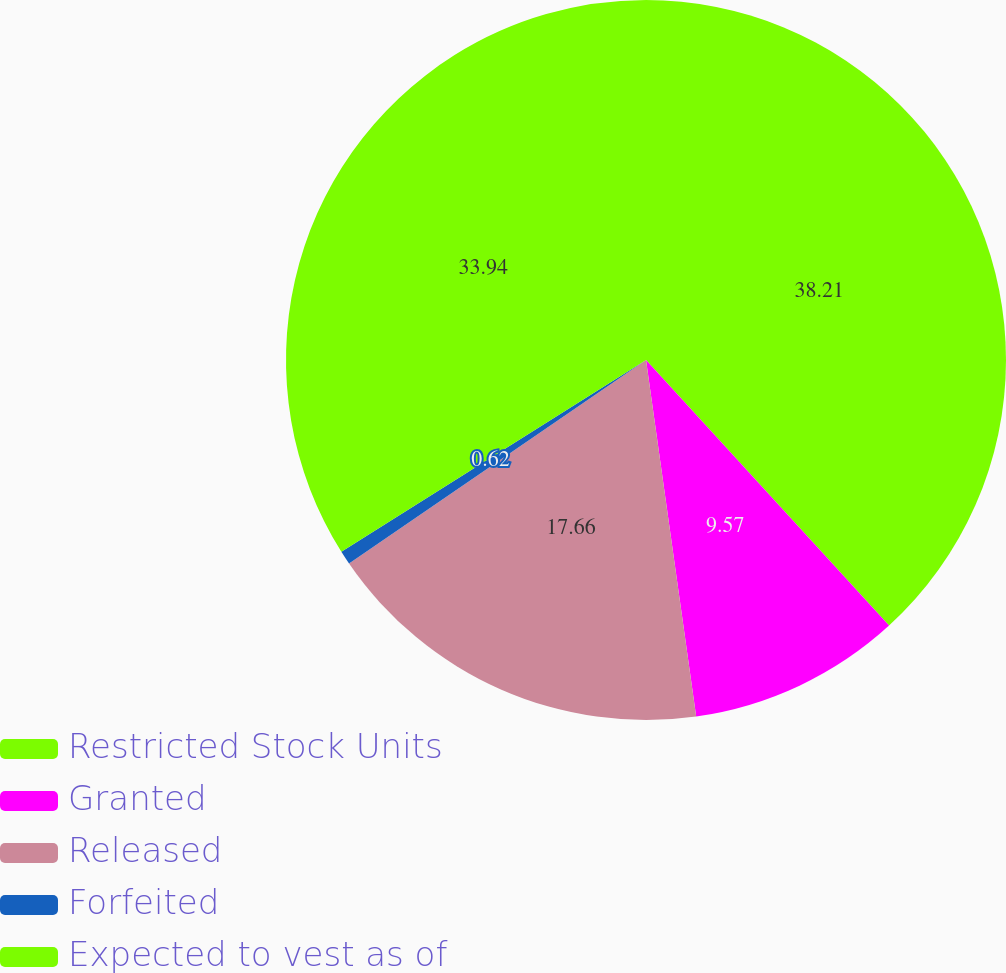Convert chart. <chart><loc_0><loc_0><loc_500><loc_500><pie_chart><fcel>Restricted Stock Units<fcel>Granted<fcel>Released<fcel>Forfeited<fcel>Expected to vest as of<nl><fcel>38.2%<fcel>9.57%<fcel>17.66%<fcel>0.62%<fcel>33.94%<nl></chart> 